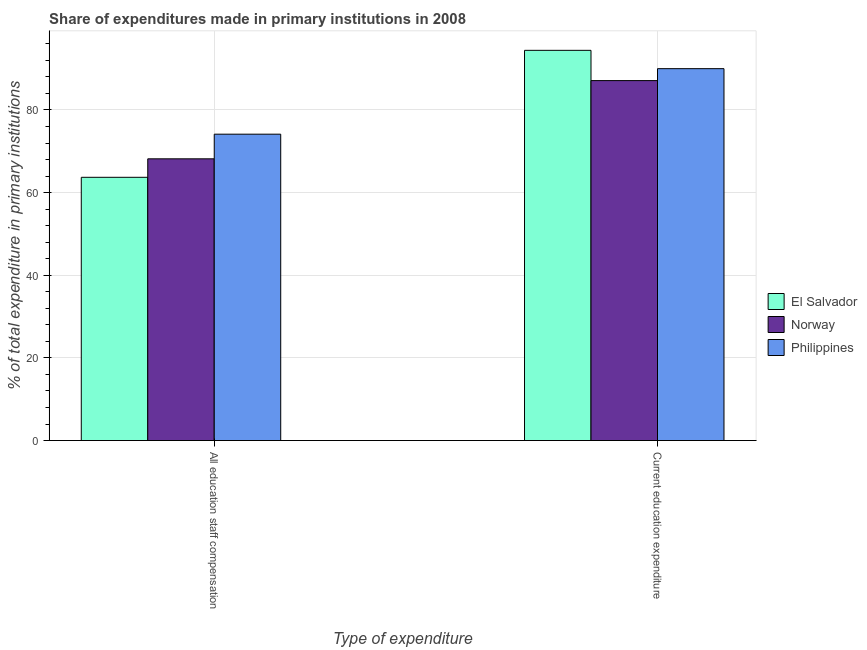Are the number of bars per tick equal to the number of legend labels?
Provide a succinct answer. Yes. How many bars are there on the 2nd tick from the left?
Provide a short and direct response. 3. How many bars are there on the 1st tick from the right?
Your answer should be compact. 3. What is the label of the 1st group of bars from the left?
Provide a short and direct response. All education staff compensation. What is the expenditure in staff compensation in Norway?
Offer a terse response. 68.17. Across all countries, what is the maximum expenditure in staff compensation?
Provide a succinct answer. 74.14. Across all countries, what is the minimum expenditure in staff compensation?
Offer a terse response. 63.7. In which country was the expenditure in education maximum?
Give a very brief answer. El Salvador. In which country was the expenditure in staff compensation minimum?
Ensure brevity in your answer.  El Salvador. What is the total expenditure in education in the graph?
Your answer should be very brief. 271.52. What is the difference between the expenditure in staff compensation in Norway and that in El Salvador?
Provide a short and direct response. 4.47. What is the difference between the expenditure in education in Norway and the expenditure in staff compensation in Philippines?
Make the answer very short. 12.96. What is the average expenditure in staff compensation per country?
Your answer should be compact. 68.67. What is the difference between the expenditure in staff compensation and expenditure in education in El Salvador?
Offer a terse response. -30.72. What is the ratio of the expenditure in education in Philippines to that in Norway?
Ensure brevity in your answer.  1.03. Is the expenditure in education in Norway less than that in Philippines?
Provide a succinct answer. Yes. What does the 3rd bar from the left in All education staff compensation represents?
Keep it short and to the point. Philippines. How many bars are there?
Offer a very short reply. 6. How many countries are there in the graph?
Your answer should be compact. 3. Are the values on the major ticks of Y-axis written in scientific E-notation?
Provide a succinct answer. No. Does the graph contain any zero values?
Your response must be concise. No. How many legend labels are there?
Keep it short and to the point. 3. What is the title of the graph?
Make the answer very short. Share of expenditures made in primary institutions in 2008. Does "Maldives" appear as one of the legend labels in the graph?
Ensure brevity in your answer.  No. What is the label or title of the X-axis?
Give a very brief answer. Type of expenditure. What is the label or title of the Y-axis?
Your response must be concise. % of total expenditure in primary institutions. What is the % of total expenditure in primary institutions of El Salvador in All education staff compensation?
Offer a terse response. 63.7. What is the % of total expenditure in primary institutions in Norway in All education staff compensation?
Ensure brevity in your answer.  68.17. What is the % of total expenditure in primary institutions in Philippines in All education staff compensation?
Make the answer very short. 74.14. What is the % of total expenditure in primary institutions in El Salvador in Current education expenditure?
Offer a terse response. 94.42. What is the % of total expenditure in primary institutions of Norway in Current education expenditure?
Provide a succinct answer. 87.1. What is the % of total expenditure in primary institutions of Philippines in Current education expenditure?
Your response must be concise. 89.99. Across all Type of expenditure, what is the maximum % of total expenditure in primary institutions of El Salvador?
Give a very brief answer. 94.42. Across all Type of expenditure, what is the maximum % of total expenditure in primary institutions in Norway?
Provide a short and direct response. 87.1. Across all Type of expenditure, what is the maximum % of total expenditure in primary institutions of Philippines?
Your answer should be compact. 89.99. Across all Type of expenditure, what is the minimum % of total expenditure in primary institutions of El Salvador?
Keep it short and to the point. 63.7. Across all Type of expenditure, what is the minimum % of total expenditure in primary institutions in Norway?
Your answer should be very brief. 68.17. Across all Type of expenditure, what is the minimum % of total expenditure in primary institutions of Philippines?
Your answer should be compact. 74.14. What is the total % of total expenditure in primary institutions of El Salvador in the graph?
Your answer should be very brief. 158.13. What is the total % of total expenditure in primary institutions in Norway in the graph?
Provide a short and direct response. 155.28. What is the total % of total expenditure in primary institutions in Philippines in the graph?
Offer a very short reply. 164.13. What is the difference between the % of total expenditure in primary institutions of El Salvador in All education staff compensation and that in Current education expenditure?
Your answer should be very brief. -30.72. What is the difference between the % of total expenditure in primary institutions in Norway in All education staff compensation and that in Current education expenditure?
Your answer should be very brief. -18.93. What is the difference between the % of total expenditure in primary institutions of Philippines in All education staff compensation and that in Current education expenditure?
Make the answer very short. -15.85. What is the difference between the % of total expenditure in primary institutions in El Salvador in All education staff compensation and the % of total expenditure in primary institutions in Norway in Current education expenditure?
Offer a terse response. -23.4. What is the difference between the % of total expenditure in primary institutions in El Salvador in All education staff compensation and the % of total expenditure in primary institutions in Philippines in Current education expenditure?
Your response must be concise. -26.29. What is the difference between the % of total expenditure in primary institutions in Norway in All education staff compensation and the % of total expenditure in primary institutions in Philippines in Current education expenditure?
Provide a short and direct response. -21.82. What is the average % of total expenditure in primary institutions in El Salvador per Type of expenditure?
Your response must be concise. 79.06. What is the average % of total expenditure in primary institutions of Norway per Type of expenditure?
Give a very brief answer. 77.64. What is the average % of total expenditure in primary institutions of Philippines per Type of expenditure?
Ensure brevity in your answer.  82.06. What is the difference between the % of total expenditure in primary institutions of El Salvador and % of total expenditure in primary institutions of Norway in All education staff compensation?
Your answer should be very brief. -4.47. What is the difference between the % of total expenditure in primary institutions of El Salvador and % of total expenditure in primary institutions of Philippines in All education staff compensation?
Make the answer very short. -10.43. What is the difference between the % of total expenditure in primary institutions in Norway and % of total expenditure in primary institutions in Philippines in All education staff compensation?
Your answer should be very brief. -5.96. What is the difference between the % of total expenditure in primary institutions of El Salvador and % of total expenditure in primary institutions of Norway in Current education expenditure?
Make the answer very short. 7.32. What is the difference between the % of total expenditure in primary institutions of El Salvador and % of total expenditure in primary institutions of Philippines in Current education expenditure?
Make the answer very short. 4.43. What is the difference between the % of total expenditure in primary institutions of Norway and % of total expenditure in primary institutions of Philippines in Current education expenditure?
Your response must be concise. -2.89. What is the ratio of the % of total expenditure in primary institutions of El Salvador in All education staff compensation to that in Current education expenditure?
Make the answer very short. 0.67. What is the ratio of the % of total expenditure in primary institutions of Norway in All education staff compensation to that in Current education expenditure?
Your response must be concise. 0.78. What is the ratio of the % of total expenditure in primary institutions of Philippines in All education staff compensation to that in Current education expenditure?
Ensure brevity in your answer.  0.82. What is the difference between the highest and the second highest % of total expenditure in primary institutions of El Salvador?
Your answer should be compact. 30.72. What is the difference between the highest and the second highest % of total expenditure in primary institutions in Norway?
Keep it short and to the point. 18.93. What is the difference between the highest and the second highest % of total expenditure in primary institutions of Philippines?
Ensure brevity in your answer.  15.85. What is the difference between the highest and the lowest % of total expenditure in primary institutions of El Salvador?
Keep it short and to the point. 30.72. What is the difference between the highest and the lowest % of total expenditure in primary institutions in Norway?
Keep it short and to the point. 18.93. What is the difference between the highest and the lowest % of total expenditure in primary institutions in Philippines?
Your answer should be compact. 15.85. 